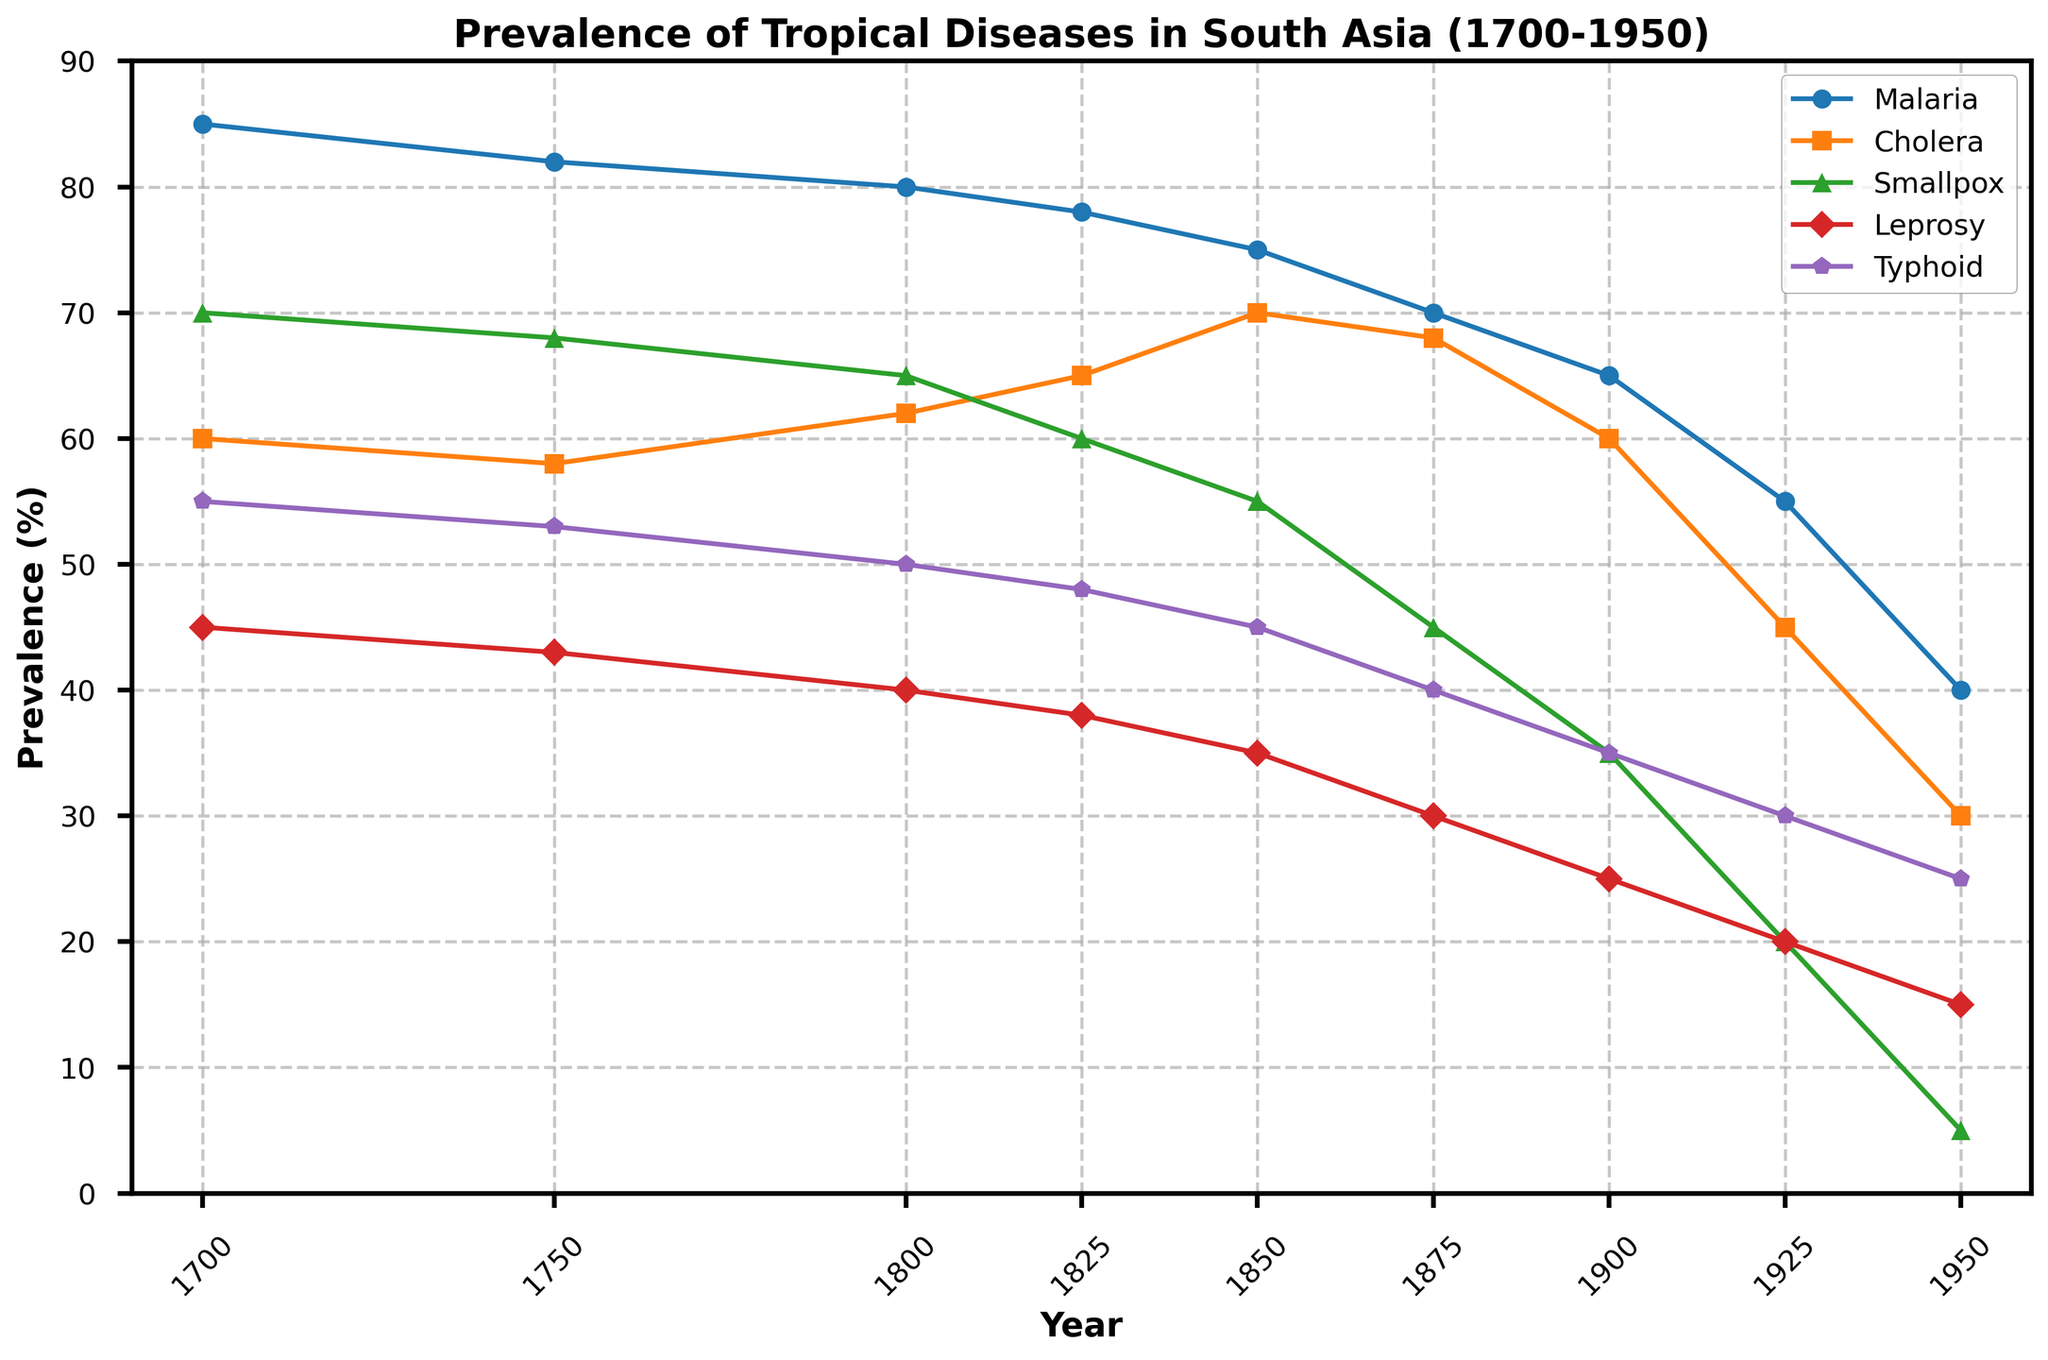What year did malaria prevalence start to show a noticeable decline? The line for malaria starts to noticeably decline around the year 1850 on the plot.
Answer: 1850 Between which years did the prevalence of smallpox decrease the most? The biggest drop in smallpox prevalence occurs between 1900 and 1925, as shown by the steepest slope in the corresponding line.
Answer: 1900-1925 Which disease had the highest prevalence in 1700? By visually comparing the heights of the initial points of all disease lines, malaria had the highest prevalence at 85%.
Answer: Malaria How does the prevalence of cholera in 1925 compare to that in 1950? The prevalence of cholera is 45% in 1925 and drops to 30% in 1950; hence, it decreases by 15%.
Answer: Decreased by 15% What is the average prevalence of typhoid between 1700 and 1950? The prevalence values for typhoid are 55, 53, 50, 48, 45, 40, 35, 30, and 25. Summing these gives a total of 381. Dividing by 9 (the number of years) gives an average of 42.33%.
Answer: 42.33% Which disease showed the least decrease in prevalence from 1825 to 1950? By assessing the drop for each disease from 1825 to 1950, leprosy drops only from 38% to 15%, a difference of 23%, which is the smallest decrease compared to other diseases.
Answer: Leprosy During which period did typhoid show the fastest decline? By examining the typhoid line, the steepest decline appears between 1875 and 1900.
Answer: 1875-1900 What was the prevalence of smallpox in 1750, and how does it compare to that in 1950? From the chart, the smallpox prevalence was 68% in 1750 and 5% in 1950. The decline is 68% - 5% = 63%.
Answer: Decline of 63% Identify the year when both cholera and malaria prevalence were equal. By analyzing the plot's intersections, cholera (58%) and malaria (55%) are never exactly equal; however, they are closest around 1925 where both are between 55 - 60%.
Answer: Closest in 1925 